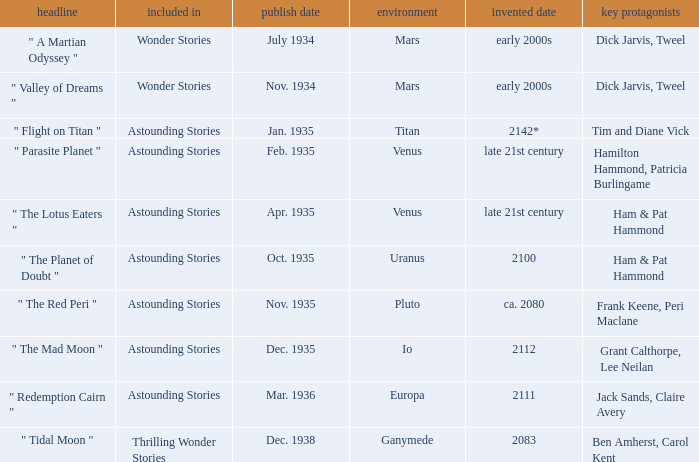Identify the release date when the imaginary year is 211 Dec. 1935. 